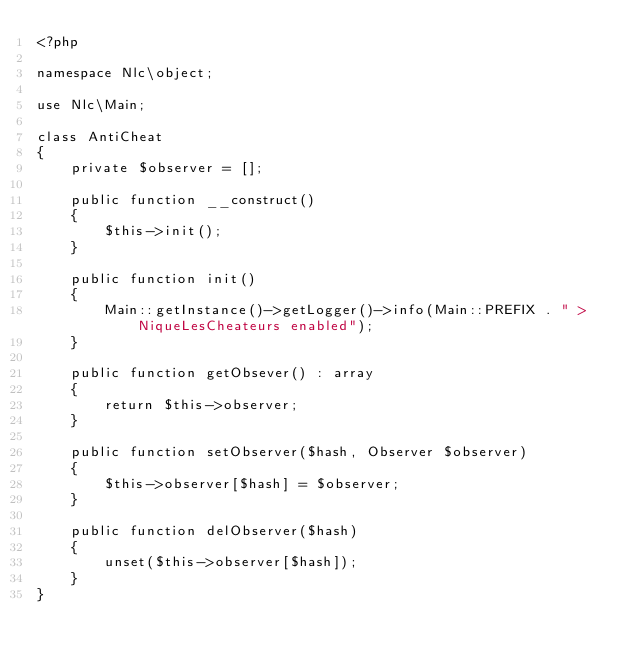Convert code to text. <code><loc_0><loc_0><loc_500><loc_500><_PHP_><?php

namespace Nlc\object;

use Nlc\Main;

class AntiCheat
{
    private $observer = [];

    public function __construct()
    {
        $this->init();
    }

    public function init()
    {
        Main::getInstance()->getLogger()->info(Main::PREFIX . " > NiqueLesCheateurs enabled");
    }

    public function getObsever() : array
    {
        return $this->observer;
    }

    public function setObserver($hash, Observer $observer)
    {
        $this->observer[$hash] = $observer;
    }

    public function delObserver($hash)
    {
        unset($this->observer[$hash]);
    }
}</code> 